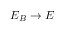Convert formula to latex. <formula><loc_0><loc_0><loc_500><loc_500>E _ { B } \to E</formula> 